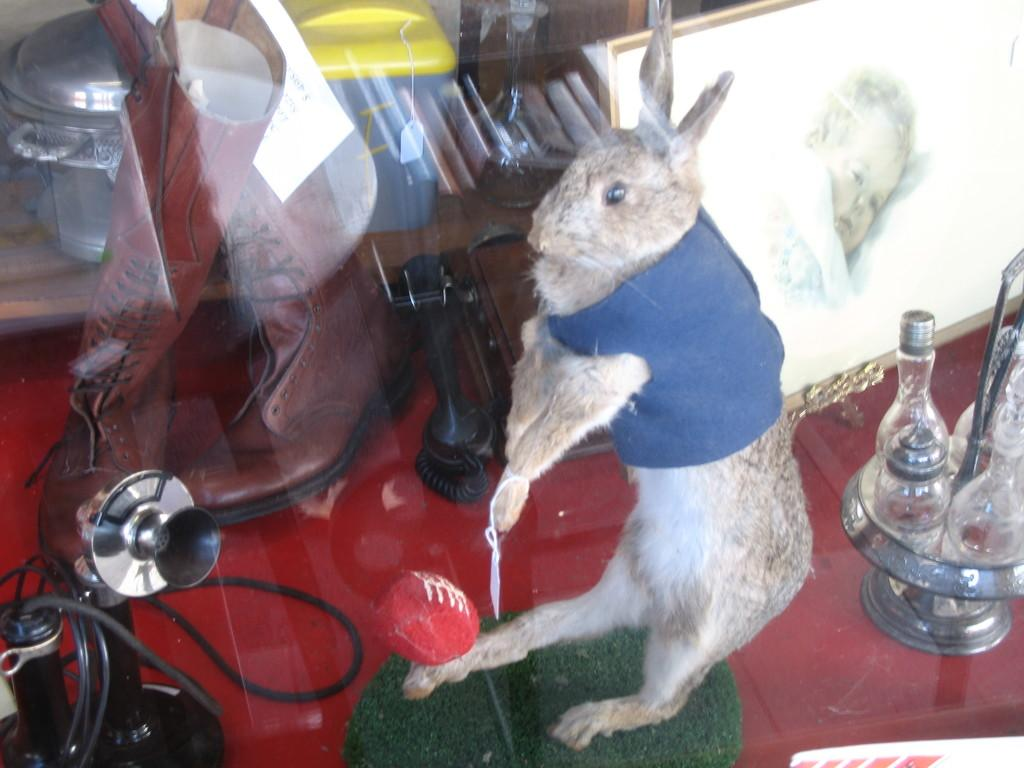What type of animal can be seen in the image? There is an animal in the image that resembles a rabbit. What is the purpose of the photo frame in the image? The purpose of the photo frame in the image is to hold a photograph or picture. What is the function of the lamp in the image? The lamp in the image provides light. Can you describe some of the other objects in the image? Unfortunately, the provided facts do not specify what the other objects in the image are. What is the answer to the riddle written on the wall in the image? There is no riddle written on the wall in the image. What type of stick is being used by the rabbit to achieve its goals in the image? There is no rabbit using a stick to achieve its goals in the image. 